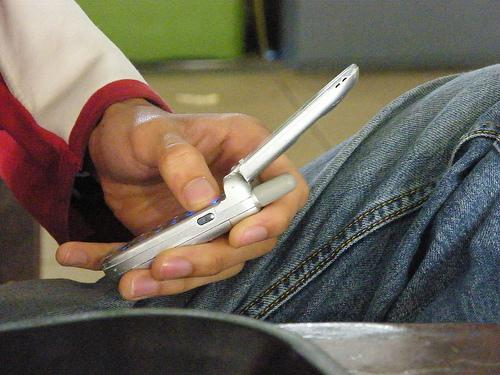Question: what hand holds the phone?
Choices:
A. A right hand.
B. Neither hand.
C. A left hand.
D. Both hands.
Answer with the letter. Answer: C Question: what color is the phone?
Choices:
A. Silver.
B. Black.
C. White.
D. Red.
Answer with the letter. Answer: A 